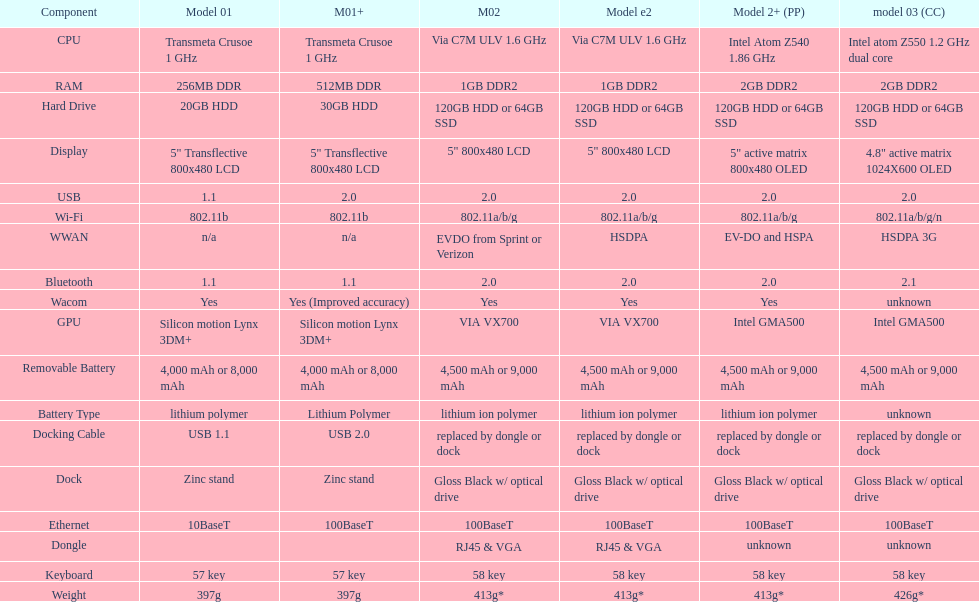Would you be able to parse every entry in this table? {'header': ['Component', 'Model 01', 'M01+', 'M02', 'Model e2', 'Model 2+ (PP)', 'model 03 (CC)'], 'rows': [['CPU', 'Transmeta Crusoe 1\xa0GHz', 'Transmeta Crusoe 1\xa0GHz', 'Via C7M ULV 1.6\xa0GHz', 'Via C7M ULV 1.6\xa0GHz', 'Intel Atom Z540 1.86\xa0GHz', 'Intel atom Z550 1.2\xa0GHz dual core'], ['RAM', '256MB DDR', '512MB DDR', '1GB DDR2', '1GB DDR2', '2GB DDR2', '2GB DDR2'], ['Hard Drive', '20GB HDD', '30GB HDD', '120GB HDD or 64GB SSD', '120GB HDD or 64GB SSD', '120GB HDD or 64GB SSD', '120GB HDD or 64GB SSD'], ['Display', '5" Transflective 800x480 LCD', '5" Transflective 800x480 LCD', '5" 800x480 LCD', '5" 800x480 LCD', '5" active matrix 800x480 OLED', '4.8" active matrix 1024X600 OLED'], ['USB', '1.1', '2.0', '2.0', '2.0', '2.0', '2.0'], ['Wi-Fi', '802.11b', '802.11b', '802.11a/b/g', '802.11a/b/g', '802.11a/b/g', '802.11a/b/g/n'], ['WWAN', 'n/a', 'n/a', 'EVDO from Sprint or Verizon', 'HSDPA', 'EV-DO and HSPA', 'HSDPA 3G'], ['Bluetooth', '1.1', '1.1', '2.0', '2.0', '2.0', '2.1'], ['Wacom', 'Yes', 'Yes (Improved accuracy)', 'Yes', 'Yes', 'Yes', 'unknown'], ['GPU', 'Silicon motion Lynx 3DM+', 'Silicon motion Lynx 3DM+', 'VIA VX700', 'VIA VX700', 'Intel GMA500', 'Intel GMA500'], ['Removable Battery', '4,000 mAh or 8,000 mAh', '4,000 mAh or 8,000 mAh', '4,500 mAh or 9,000 mAh', '4,500 mAh or 9,000 mAh', '4,500 mAh or 9,000 mAh', '4,500 mAh or 9,000 mAh'], ['Battery Type', 'lithium polymer', 'Lithium Polymer', 'lithium ion polymer', 'lithium ion polymer', 'lithium ion polymer', 'unknown'], ['Docking Cable', 'USB 1.1', 'USB 2.0', 'replaced by dongle or dock', 'replaced by dongle or dock', 'replaced by dongle or dock', 'replaced by dongle or dock'], ['Dock', 'Zinc stand', 'Zinc stand', 'Gloss Black w/ optical drive', 'Gloss Black w/ optical drive', 'Gloss Black w/ optical drive', 'Gloss Black w/ optical drive'], ['Ethernet', '10BaseT', '100BaseT', '100BaseT', '100BaseT', '100BaseT', '100BaseT'], ['Dongle', '', '', 'RJ45 & VGA', 'RJ45 & VGA', 'unknown', 'unknown'], ['Keyboard', '57 key', '57 key', '58 key', '58 key', '58 key', '58 key'], ['Weight', '397g', '397g', '413g*', '413g*', '413g*', '426g*']]} What is the next highest hard drive available after the 30gb model? 64GB SSD. 